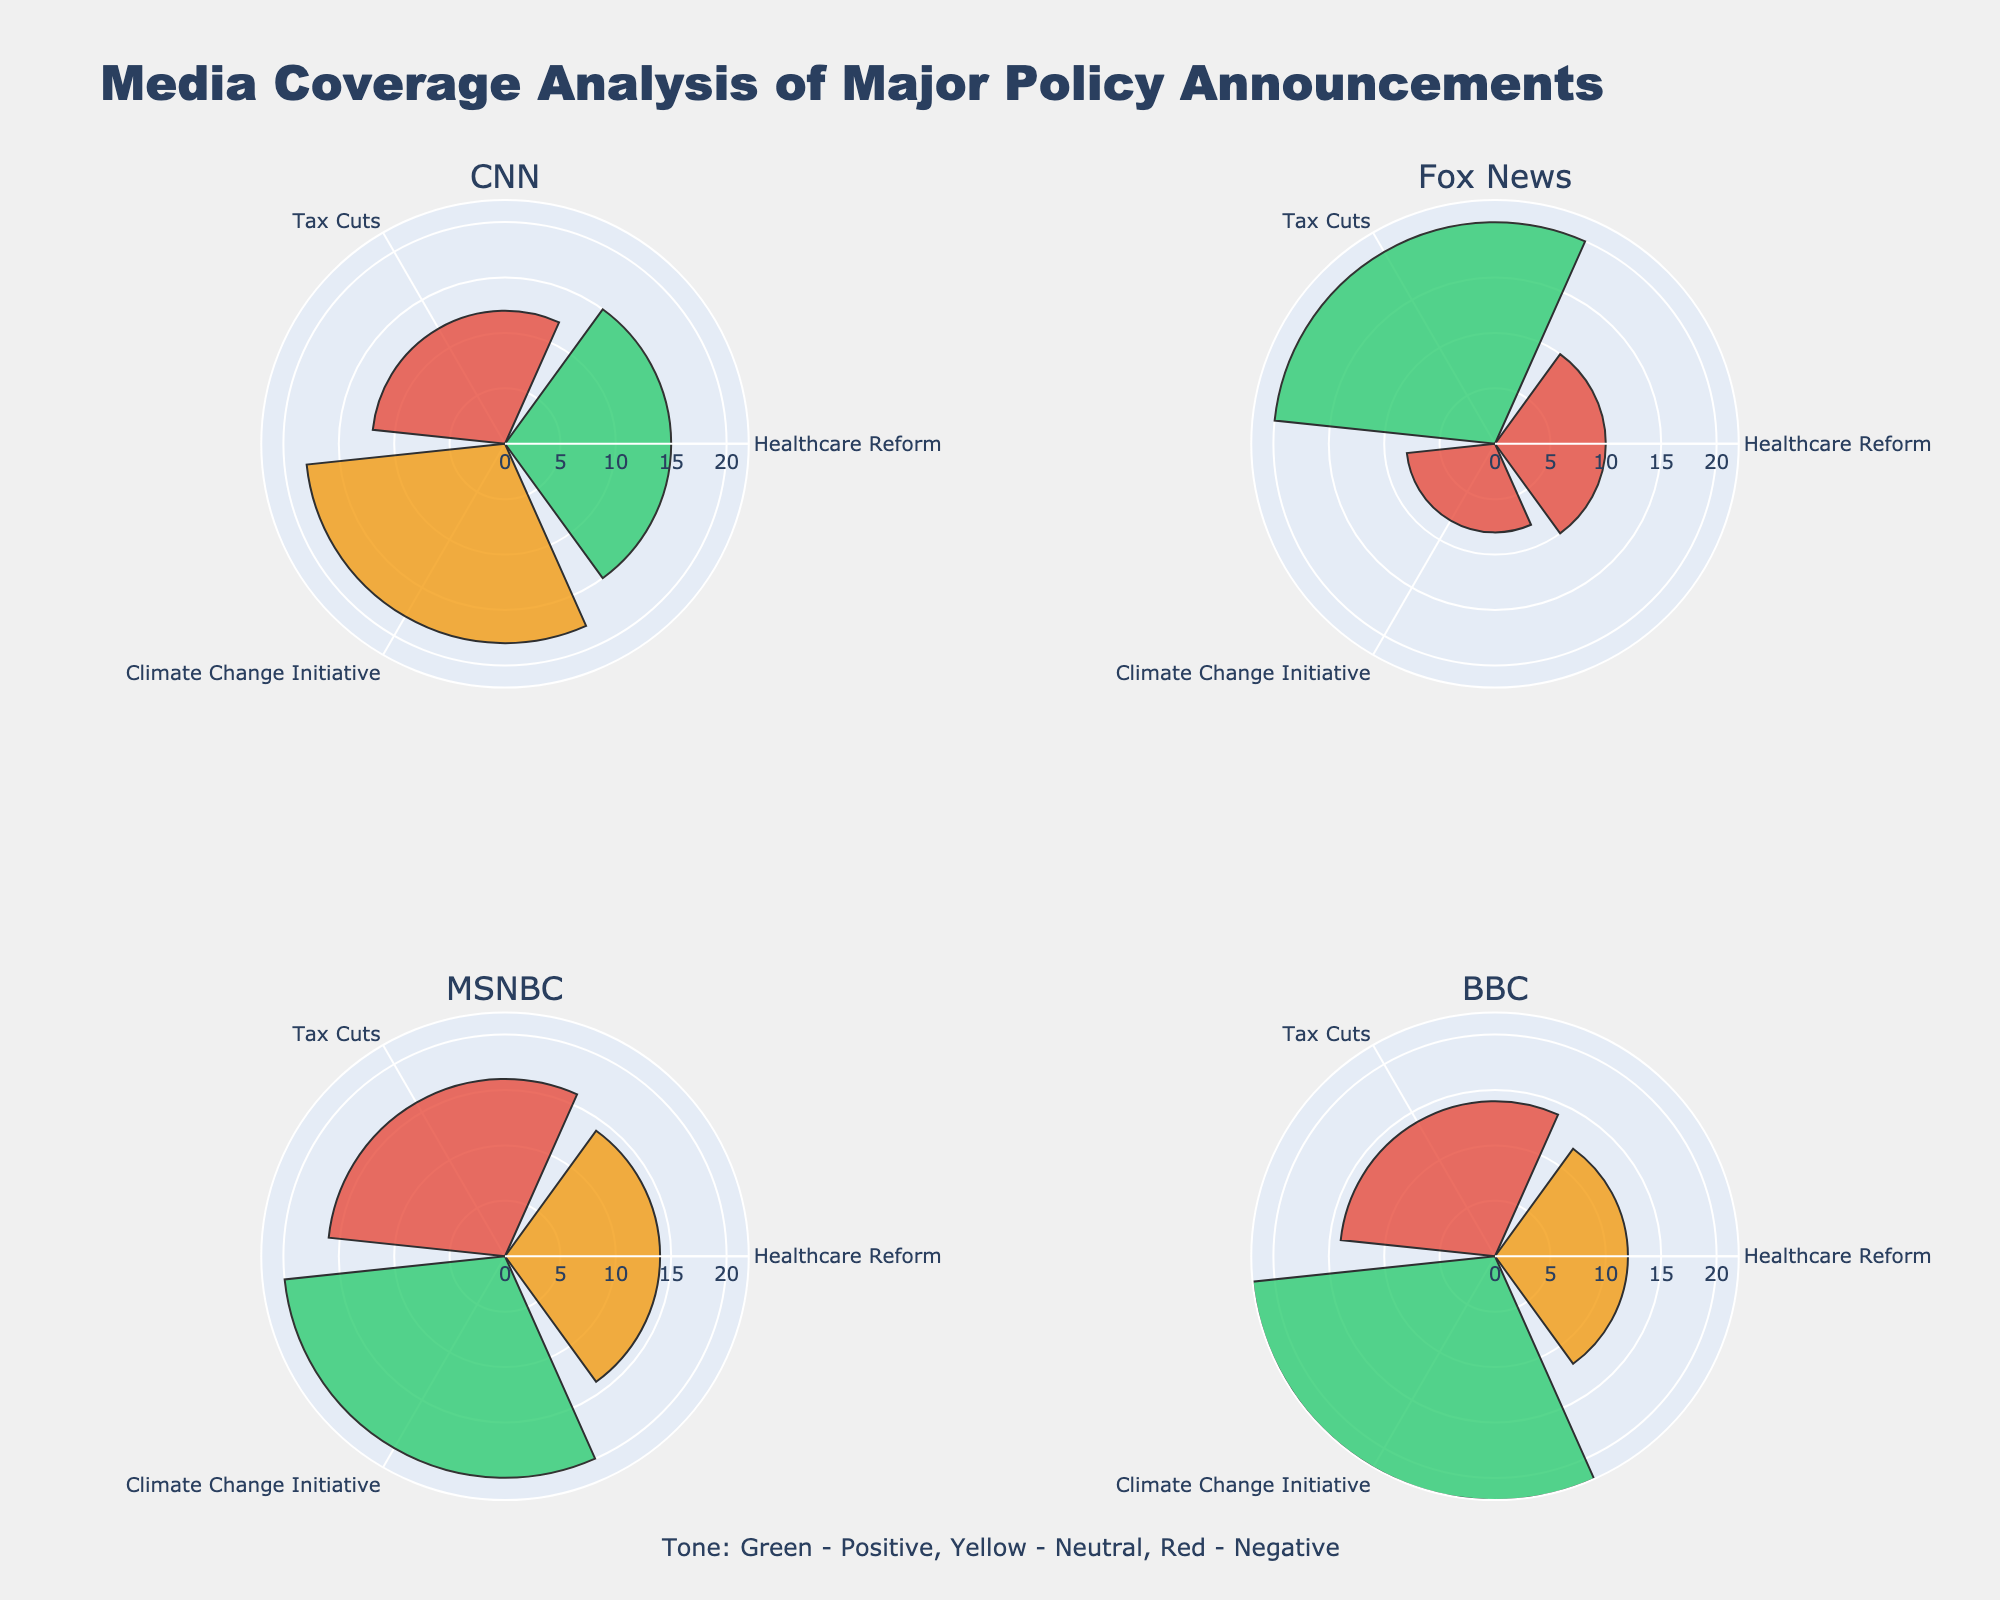What are the media outlets featured in the chart? The four subplots each have a title that indicates a different media outlet: CNN, Fox News, MSNBC, and BBC.
Answer: CNN, Fox News, MSNBC, BBC Which policy announcement received the longest coverage by Fox News? By looking at the Fox News subplot, the bar for the 'Tax Cuts' policy announcement is the longest, indicating 20 minutes of coverage.
Answer: Tax Cuts What is the total coverage length of 'Healthcare Reform' across all media outlets? Summing up the coverage lengths for 'Healthcare Reform' from each subplot: CNN (15) + Fox News (10) + MSNBC (14) + BBC (12) = 51 minutes.
Answer: 51 minutes Which media outlet had the most positive tone on 'Climate Change Initiative'? In the subplots, the 'Climate Change Initiative' bar with a green color indicates a positive tone. MSNBC and BBC both have green bars for 'Climate Change Initiative'. Among these, BBC has the longest bar at 22 minutes.
Answer: BBC For CNN, how does the tone distribution vary among different policy announcements? The CNN subplot shows one green bar for 'Healthcare Reform' (positive), one red bar for 'Tax Cuts' (negative), and one yellow bar for 'Climate Change Initiative' (neutral), thus indicating varied tones across different policies.
Answer: Varied: Positive for Healthcare Reform, Negative for Tax Cuts, Neutral for Climate Change Initiative Which policy received the shortest coverage overall, and what was the tone? By identifying the shortest bar across all subplots, 'Climate Change Initiative' on Fox News has the shortest coverage of 8 minutes, with a negative tone (red).
Answer: Climate Change Initiative, Negative Compare the coverage length and tone of 'Tax Cuts' between CNN and MSNBC. CNN's 'Tax Cuts' has a red bar (negative) with 12 minutes of coverage, while MSNBC's 'Tax Cuts' has a red bar too (negative) with 16 minutes of coverage. Thus, both tones are negative, but MSNBC has longer coverage.
Answer: Both Negative, MSNBC longer What is the average coverage length for 'Climate Change Initiative' across all media outlets? Calculating the average: (CNN (18) + Fox News (8) + MSNBC (20) + BBC (22)) / 4 = 68 / 4 = 17 minutes.
Answer: 17 minutes Which media outlet had a neutral tone for 'Healthcare Reform' and what was the coverage length? The subplot for MSNBC shows a yellow bar (neutral tone) for 'Healthcare Reform' with a length of 14 minutes. Similarly, BBC also shows a yellow bar with 12 minutes. Therefore, two outlets had a neutral tone.
Answer: MSNBC (14), BBC (12) What is the sum of the positive-toned coverage lengths for all policies by BBC? Looking at the BBC subplot, extracting the lengths where the tone is green: 'Climate Change Initiative' (22) and adding only this since others are not positive, the sum is 22 minutes.
Answer: 22 minutes 